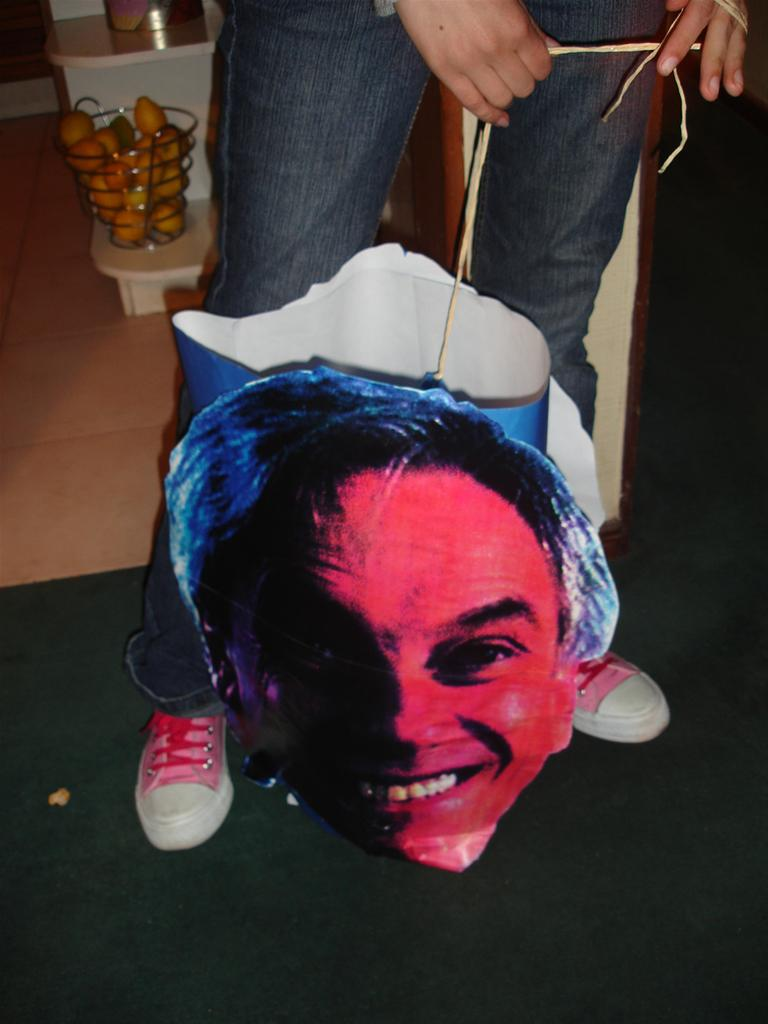What can be seen in the image? There is a person in the image. Can you describe the person's appearance? The person's face is not visible in the image. What is the person holding in the image? The person is holding a cutout with a thread. What else is present in the image? There is a basket on a table, and the basket contains fruits. What type of cover is the person using to express their love in the image? There is no cover or expression of love present in the image. The person is holding a cutout with a thread, but it is not related to love or a cover. 